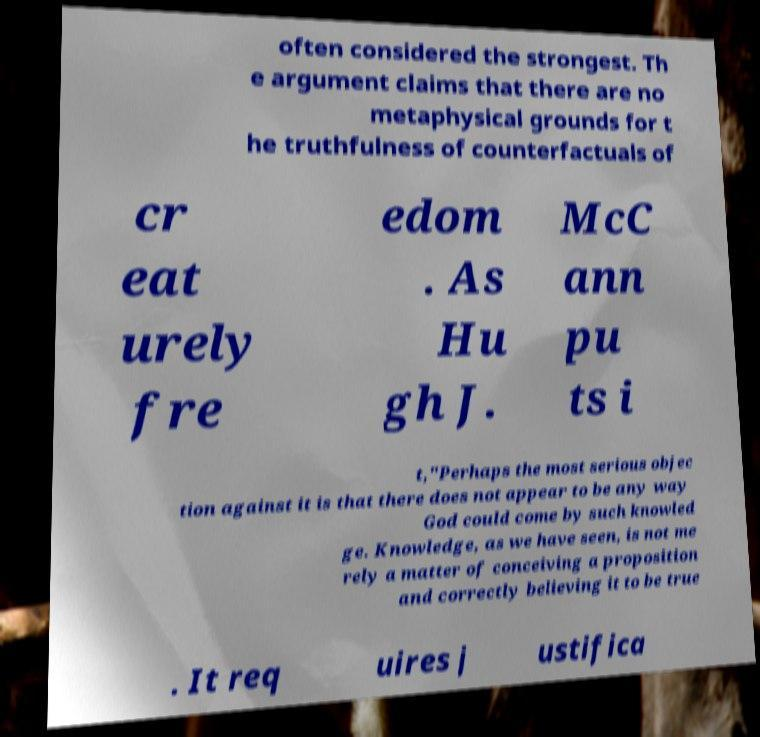What messages or text are displayed in this image? I need them in a readable, typed format. often considered the strongest. Th e argument claims that there are no metaphysical grounds for t he truthfulness of counterfactuals of cr eat urely fre edom . As Hu gh J. McC ann pu ts i t,"Perhaps the most serious objec tion against it is that there does not appear to be any way God could come by such knowled ge. Knowledge, as we have seen, is not me rely a matter of conceiving a proposition and correctly believing it to be true . It req uires j ustifica 